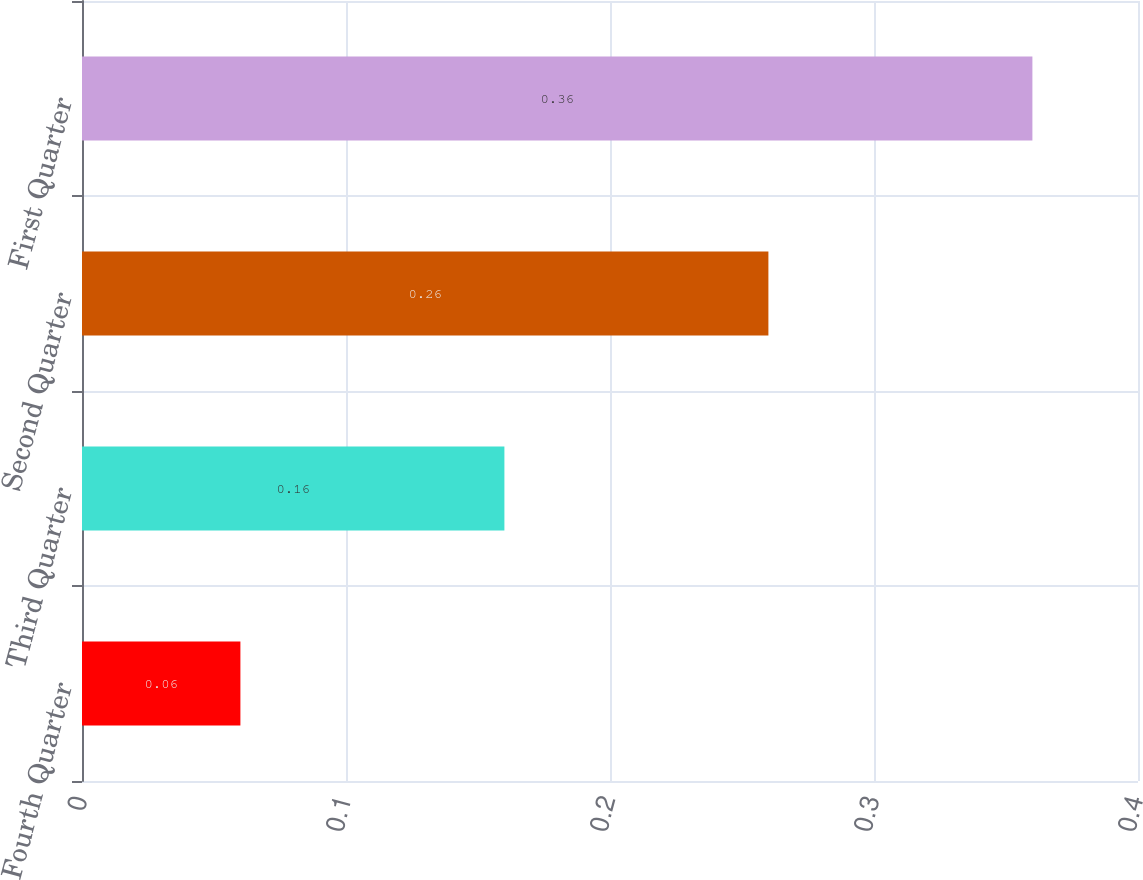Convert chart to OTSL. <chart><loc_0><loc_0><loc_500><loc_500><bar_chart><fcel>Fourth Quarter<fcel>Third Quarter<fcel>Second Quarter<fcel>First Quarter<nl><fcel>0.06<fcel>0.16<fcel>0.26<fcel>0.36<nl></chart> 